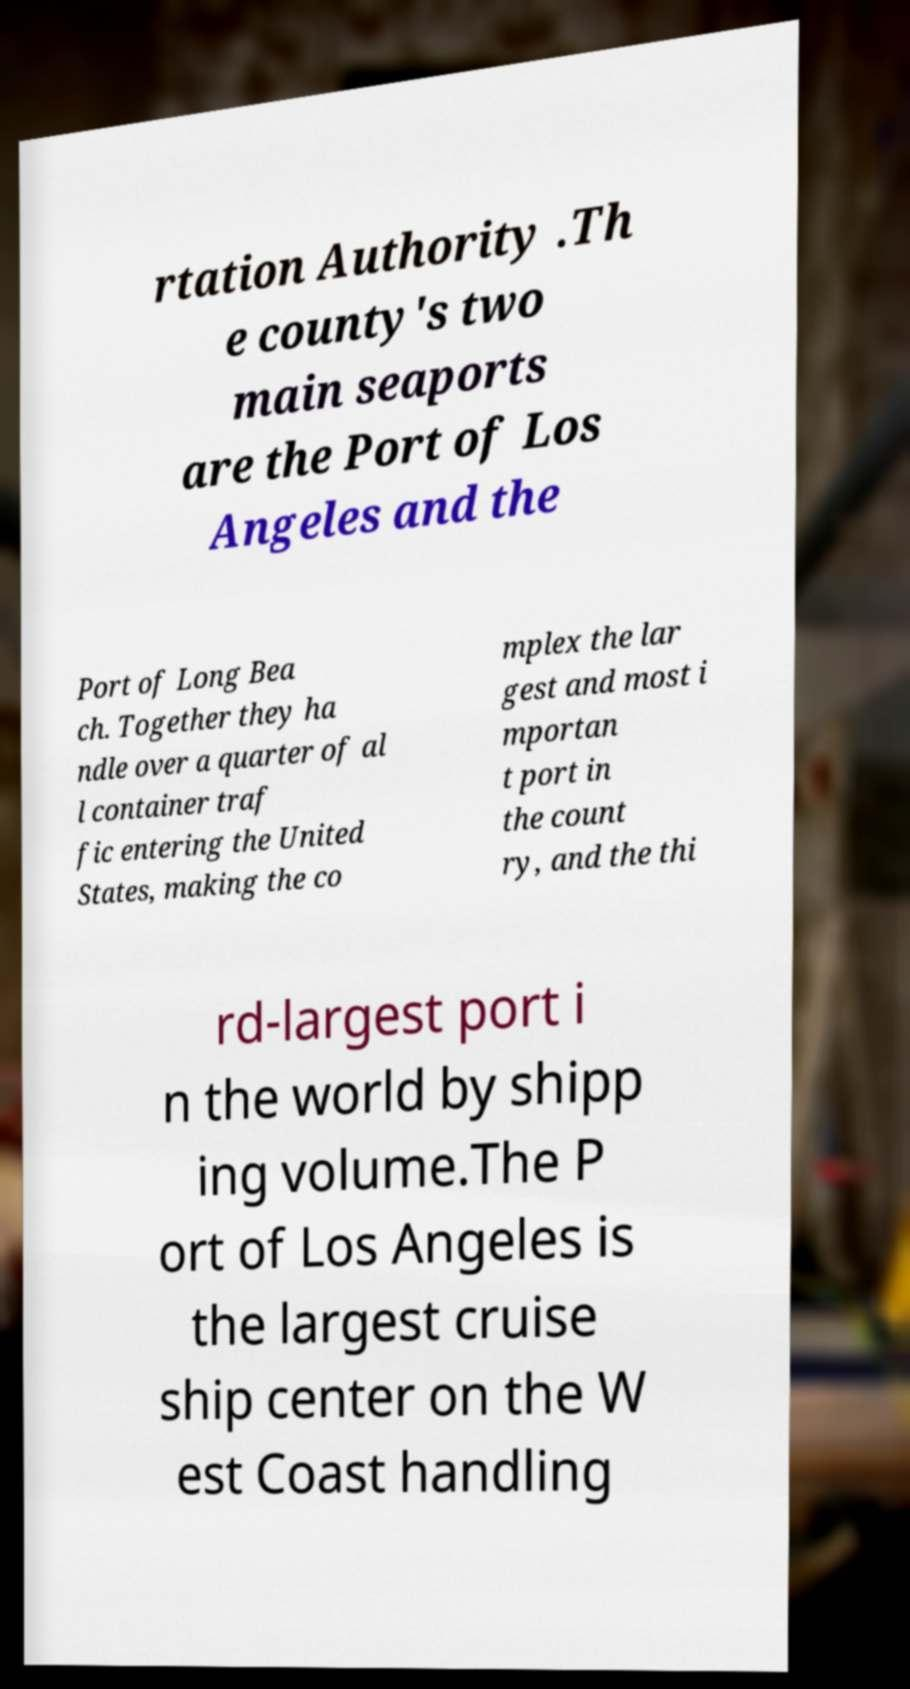Could you extract and type out the text from this image? rtation Authority .Th e county's two main seaports are the Port of Los Angeles and the Port of Long Bea ch. Together they ha ndle over a quarter of al l container traf fic entering the United States, making the co mplex the lar gest and most i mportan t port in the count ry, and the thi rd-largest port i n the world by shipp ing volume.The P ort of Los Angeles is the largest cruise ship center on the W est Coast handling 